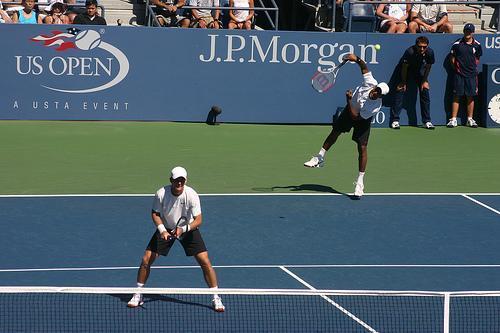How many players are in the picture?
Give a very brief answer. 2. 